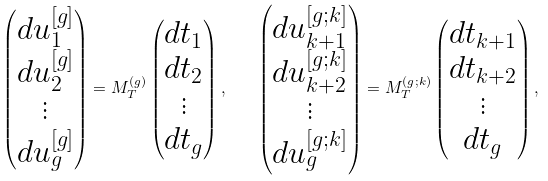Convert formula to latex. <formula><loc_0><loc_0><loc_500><loc_500>\begin{pmatrix} d u _ { 1 } ^ { [ g ] } \\ d u _ { 2 } ^ { [ g ] } \\ \vdots \\ d u _ { g } ^ { [ g ] } \\ \end{pmatrix} = M _ { T } ^ { ( g ) } \begin{pmatrix} d t _ { 1 } \\ d t _ { 2 } \\ \vdots \\ d t _ { g } \\ \end{pmatrix} , \quad \begin{pmatrix} d u _ { k + 1 } ^ { [ g ; k ] } \\ d u _ { k + 2 } ^ { [ g ; k ] } \\ \vdots \\ d u _ { g } ^ { [ g ; k ] } \\ \end{pmatrix} = M _ { T } ^ { ( g ; k ) } \begin{pmatrix} d t _ { k + 1 } \\ d t _ { k + 2 } \\ \vdots \\ d t _ { g } \\ \end{pmatrix} ,</formula> 